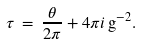Convert formula to latex. <formula><loc_0><loc_0><loc_500><loc_500>\tau \, = \, \frac { \theta } { 2 \pi } + 4 \pi i \, { \mathrm g } ^ { - 2 } .</formula> 